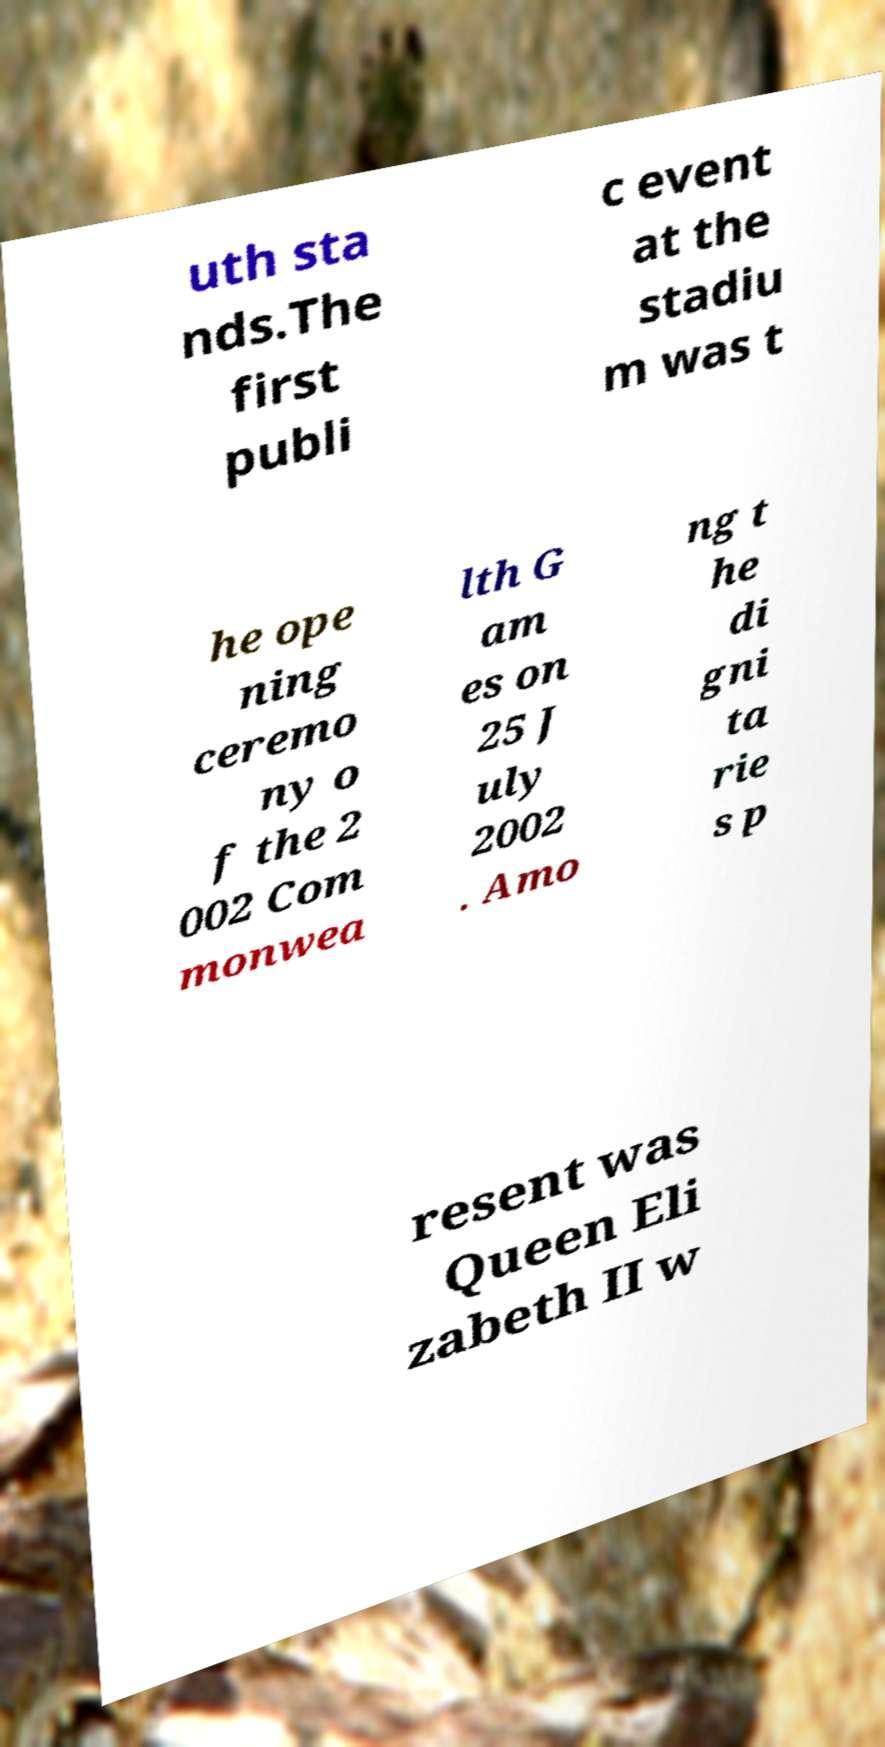There's text embedded in this image that I need extracted. Can you transcribe it verbatim? uth sta nds.The first publi c event at the stadiu m was t he ope ning ceremo ny o f the 2 002 Com monwea lth G am es on 25 J uly 2002 . Amo ng t he di gni ta rie s p resent was Queen Eli zabeth II w 